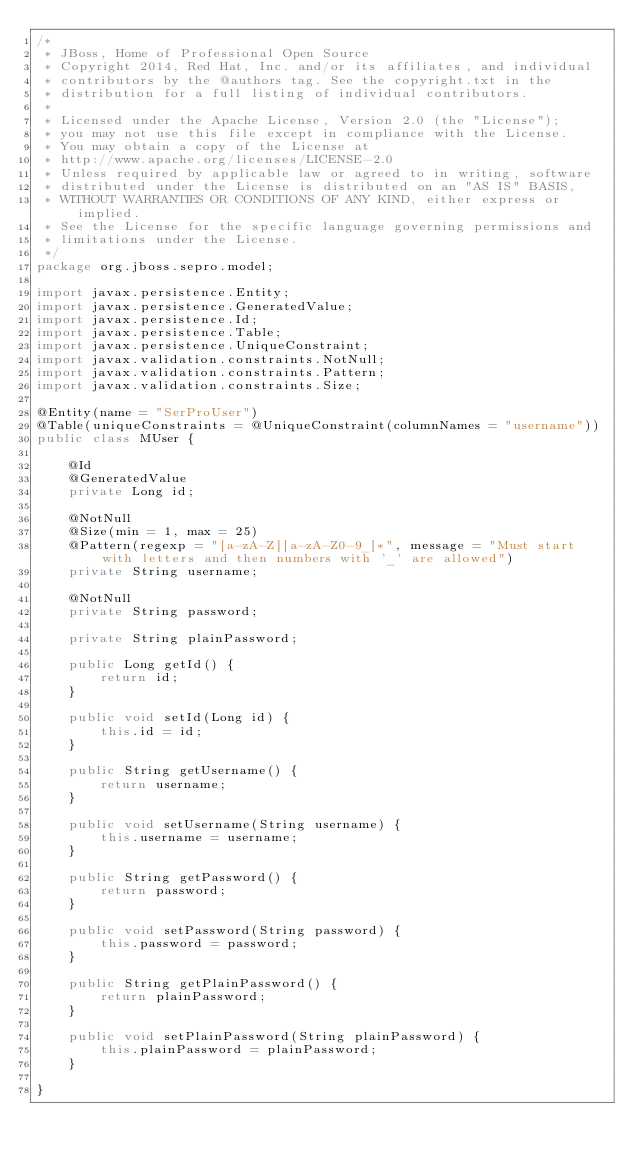Convert code to text. <code><loc_0><loc_0><loc_500><loc_500><_Java_>/*
 * JBoss, Home of Professional Open Source
 * Copyright 2014, Red Hat, Inc. and/or its affiliates, and individual
 * contributors by the @authors tag. See the copyright.txt in the
 * distribution for a full listing of individual contributors.
 *
 * Licensed under the Apache License, Version 2.0 (the "License");
 * you may not use this file except in compliance with the License.
 * You may obtain a copy of the License at
 * http://www.apache.org/licenses/LICENSE-2.0
 * Unless required by applicable law or agreed to in writing, software
 * distributed under the License is distributed on an "AS IS" BASIS,
 * WITHOUT WARRANTIES OR CONDITIONS OF ANY KIND, either express or implied.
 * See the License for the specific language governing permissions and
 * limitations under the License.
 */
package org.jboss.sepro.model;

import javax.persistence.Entity;
import javax.persistence.GeneratedValue;
import javax.persistence.Id;
import javax.persistence.Table;
import javax.persistence.UniqueConstraint;
import javax.validation.constraints.NotNull;
import javax.validation.constraints.Pattern;
import javax.validation.constraints.Size;

@Entity(name = "SerProUser")
@Table(uniqueConstraints = @UniqueConstraint(columnNames = "username"))
public class MUser {

    @Id
    @GeneratedValue
    private Long id;

    @NotNull
    @Size(min = 1, max = 25)
    @Pattern(regexp = "[a-zA-Z][a-zA-Z0-9_]*", message = "Must start with letters and then numbers with '_' are allowed")
    private String username;

    @NotNull
    private String password;

    private String plainPassword;

    public Long getId() {
        return id;
    }

    public void setId(Long id) {
        this.id = id;
    }

    public String getUsername() {
        return username;
    }

    public void setUsername(String username) {
        this.username = username;
    }

    public String getPassword() {
        return password;
    }

    public void setPassword(String password) {
        this.password = password;
    }

    public String getPlainPassword() {
        return plainPassword;
    }

    public void setPlainPassword(String plainPassword) {
        this.plainPassword = plainPassword;
    }

}
</code> 